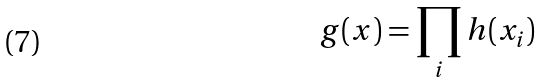<formula> <loc_0><loc_0><loc_500><loc_500>g ( x ) = \prod _ { i } h ( x _ { i } )</formula> 